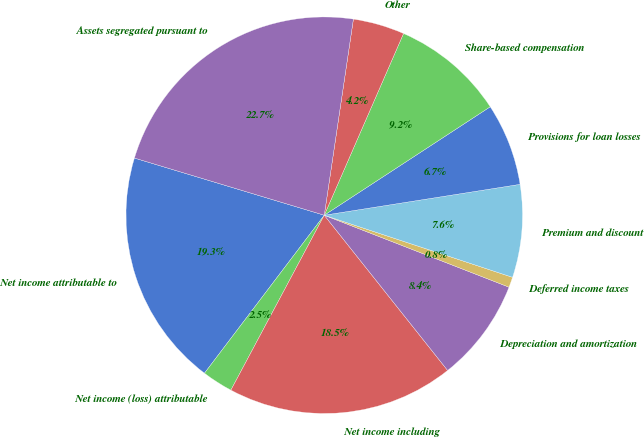<chart> <loc_0><loc_0><loc_500><loc_500><pie_chart><fcel>Net income attributable to<fcel>Net income (loss) attributable<fcel>Net income including<fcel>Depreciation and amortization<fcel>Deferred income taxes<fcel>Premium and discount<fcel>Provisions for loan losses<fcel>Share-based compensation<fcel>Other<fcel>Assets segregated pursuant to<nl><fcel>19.33%<fcel>2.52%<fcel>18.49%<fcel>8.4%<fcel>0.84%<fcel>7.56%<fcel>6.72%<fcel>9.24%<fcel>4.2%<fcel>22.69%<nl></chart> 